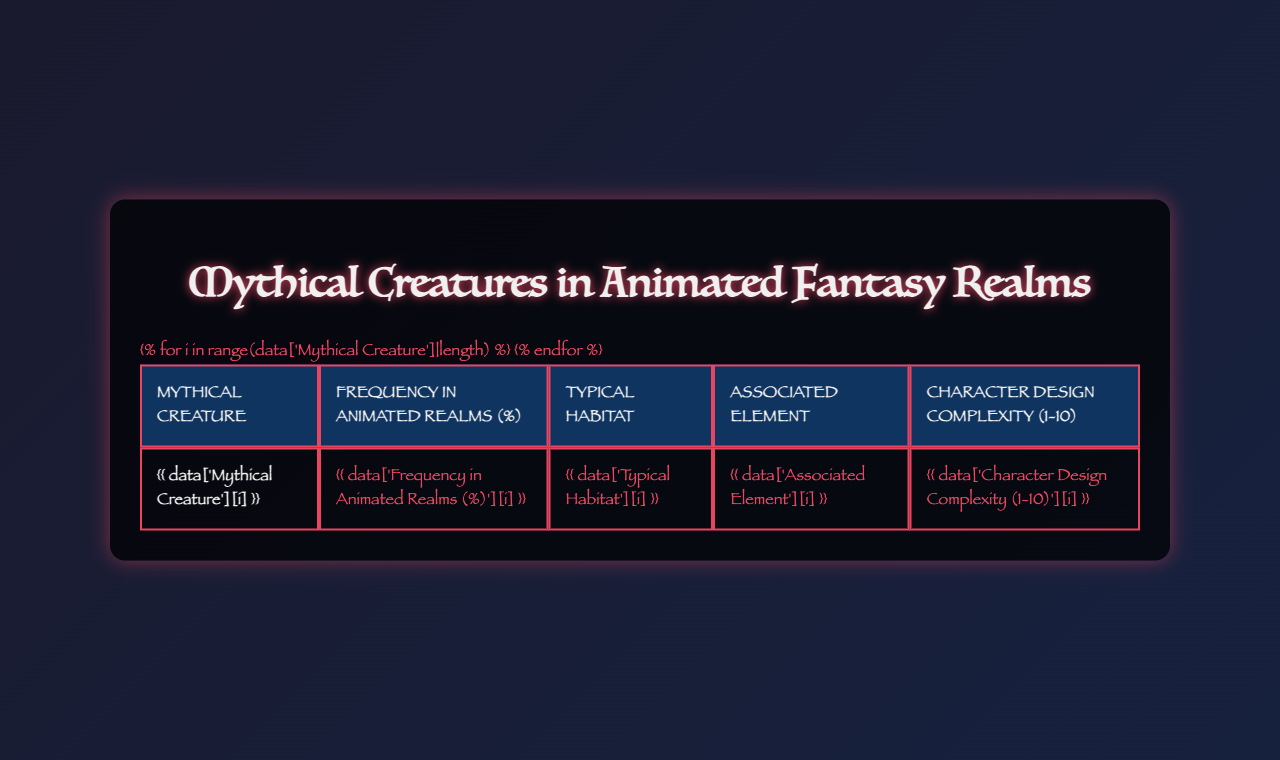What is the most common mythical creature in animated realms? The table shows the frequency of mythical creatures in animated realms. The highest frequency is 28%, corresponding to the Dragon.
Answer: Dragon Which mythical creature has the lowest frequency in animated realms? The Dragon has the highest frequency at 28%, while both the Werewolf and Chimera have the lowest frequency at 1%.
Answer: Werewolf and Chimera How many mythical creatures have a character design complexity rating of 9? From the table, there are two creatures (Dragon and Chimera) that have a complexity rating of 9.
Answer: 2 What is the typical habitat of Mermaids? The table specifies that Mermaids are typically found in Underwater Kingdoms.
Answer: Underwater Kingdoms Which mythical creature is associated with the element of Water? The table indicates that Mermaids are associated with the element Water.
Answer: Mermaid What is the average frequency of mythical creatures in animated realms? To find the average, sum the frequencies: 28 + 22 + 15 + 12 + 8 + 6 + 4 + 3 + 1 + 1 = 100. There are 10 creatures, so the average is 100/10 = 10.
Answer: 10% Which creature's typical habitat is described as "Sky Islands"? The table shows that the Griffin's typical habitat is Sky Islands.
Answer: Griffin What is the difference in character design complexity between Dragons and Mermaids? Dragons have a complexity of 9 while Mermaids have a complexity of 7. The difference is 9 - 7 = 2.
Answer: 2 Are Trolls associated with the element of Earth? The table indicates that Trolls are indeed associated with the element of Earth.
Answer: Yes What is the most complex mythical creature based on the design rating? Dragons have a complexity rating of 9, making them the most complex creature based on design.
Answer: Dragon If you combine the frequency of Unicorns and Phoenixes, do they exceed the frequency of Dragons? Unicorns (22%) and Phoenixes (15%) together sum to 37%, which exceeds Dragons' 28%.
Answer: Yes 